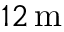<formula> <loc_0><loc_0><loc_500><loc_500>1 2 \, m</formula> 